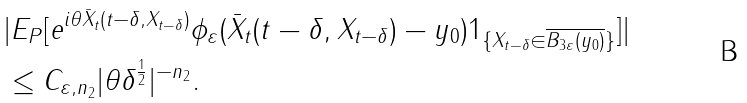<formula> <loc_0><loc_0><loc_500><loc_500>& | E _ { P } [ e ^ { i \theta \bar { X } _ { t } ( t - \delta , X _ { t - \delta } ) } \phi _ { \varepsilon } ( \bar { X } _ { t } ( t - \delta , X _ { t - \delta } ) - y _ { 0 } ) 1 _ { \{ X _ { t - \delta } \in \overline { B _ { 3 \varepsilon } ( y _ { 0 } ) } \} } ] | \\ & \leq C _ { \varepsilon , n _ { 2 } } | \theta \delta ^ { \frac { 1 } { 2 } } | ^ { - n _ { 2 } } .</formula> 